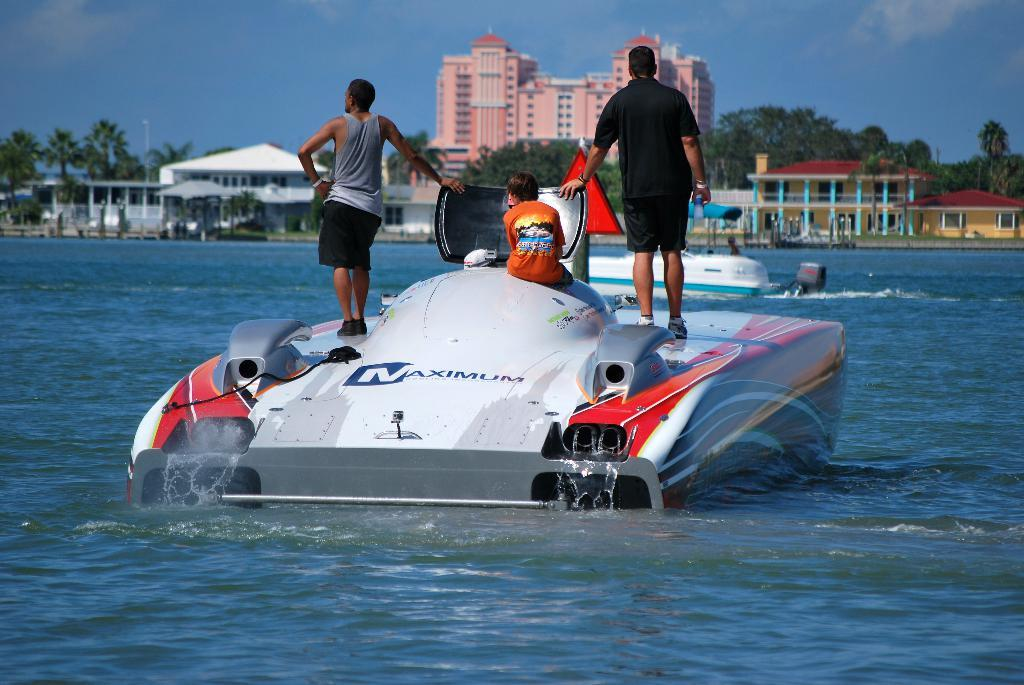How many people are on the boat in the image? There are two people standing and one person sitting on the boat, making a total of three people. What can be seen in the background of the image? Buildings and trees are visible in the background of the image. What type of rhythm is the soda creating on the boat? There is no soda present in the image, and therefore no rhythm can be observed. 